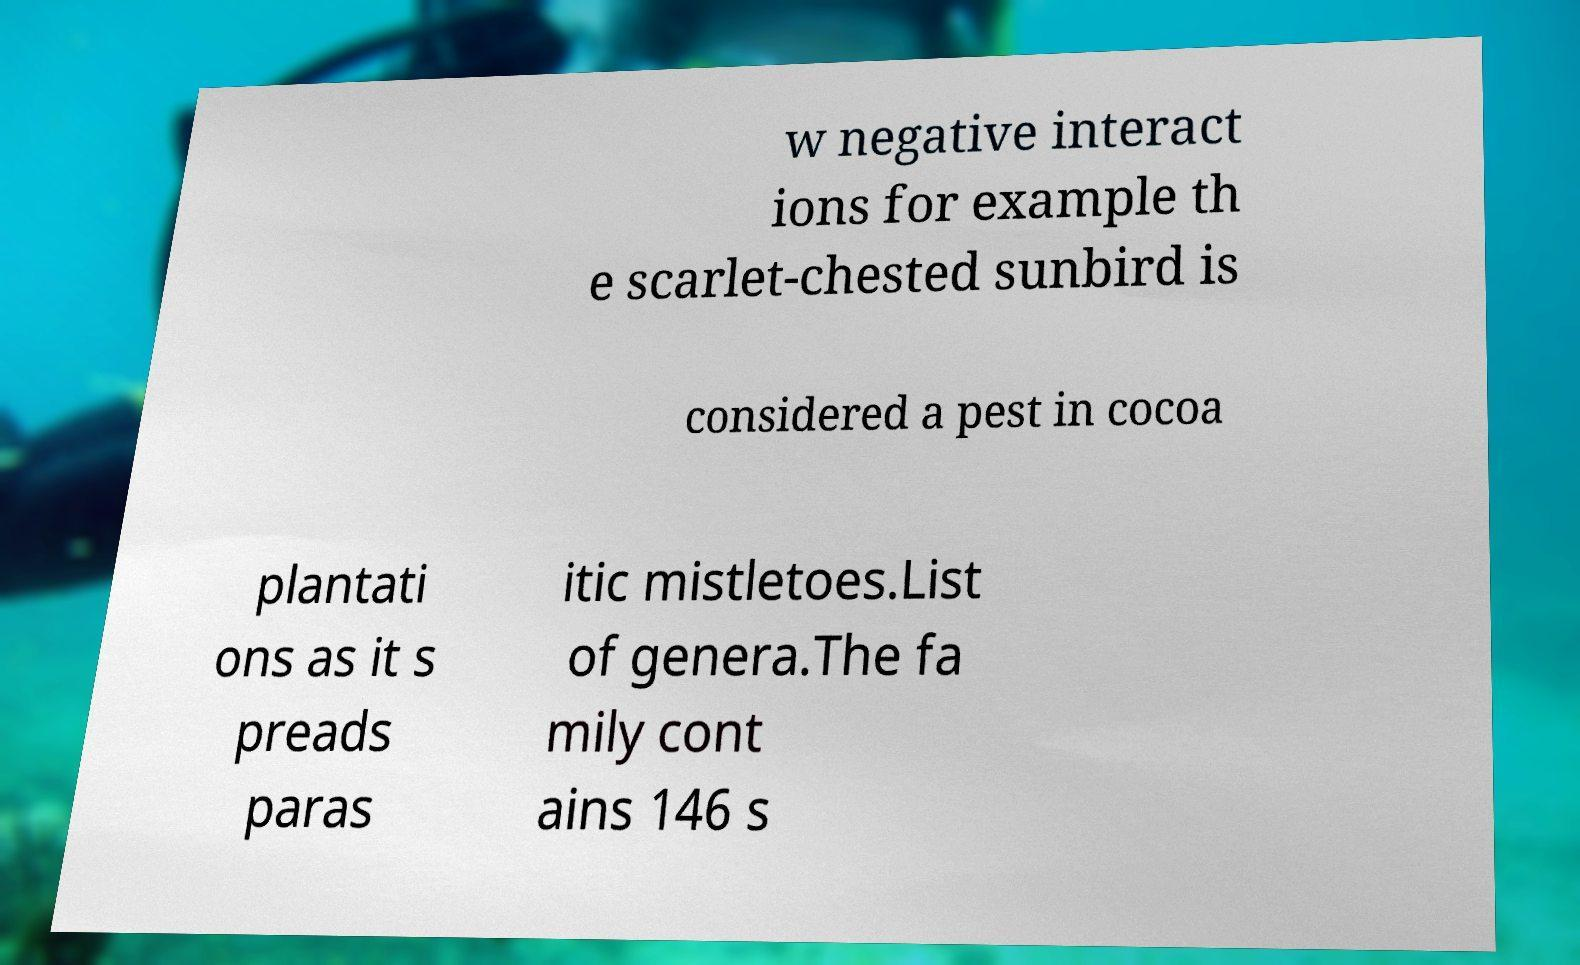For documentation purposes, I need the text within this image transcribed. Could you provide that? w negative interact ions for example th e scarlet-chested sunbird is considered a pest in cocoa plantati ons as it s preads paras itic mistletoes.List of genera.The fa mily cont ains 146 s 